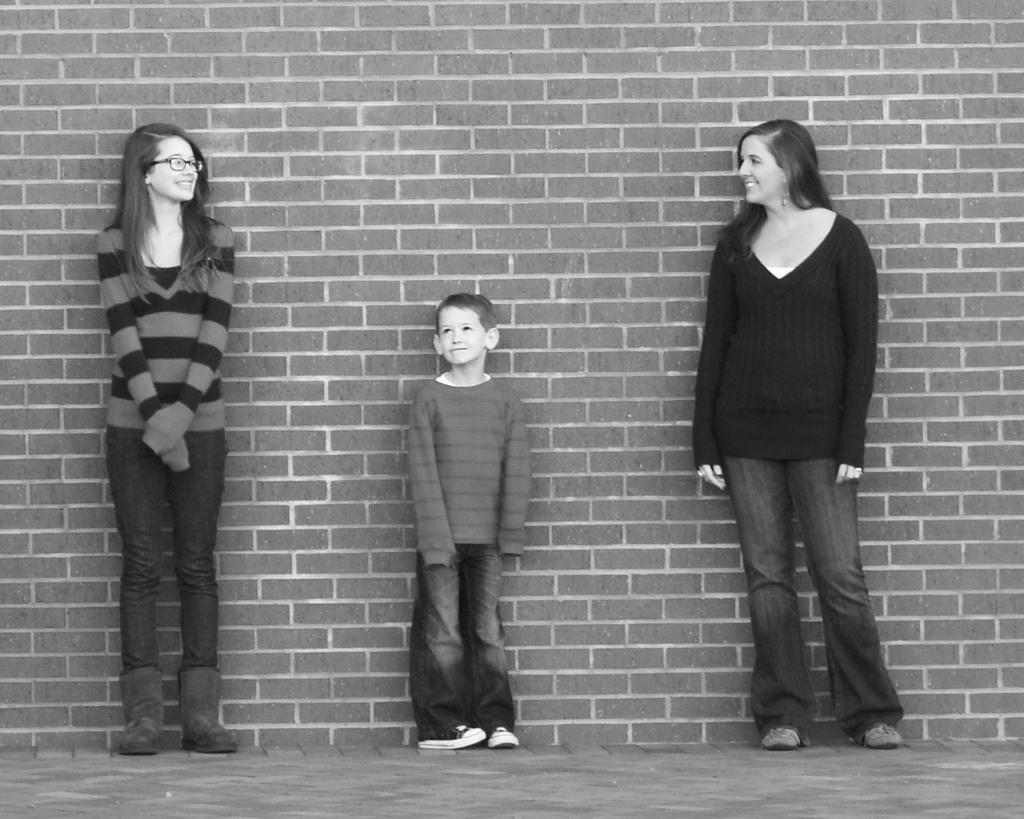What is the color scheme of the image? The image is black and white. Who is present in the image? There is a boy and two women in the image. What are the people in the image doing? The boy and women are standing on the ground. What can be seen in the background of the image? There is a brick wall in the image. What type of polish is the boy applying to the women's throats in the image? There is no polish or throat-related activity present in the image. 